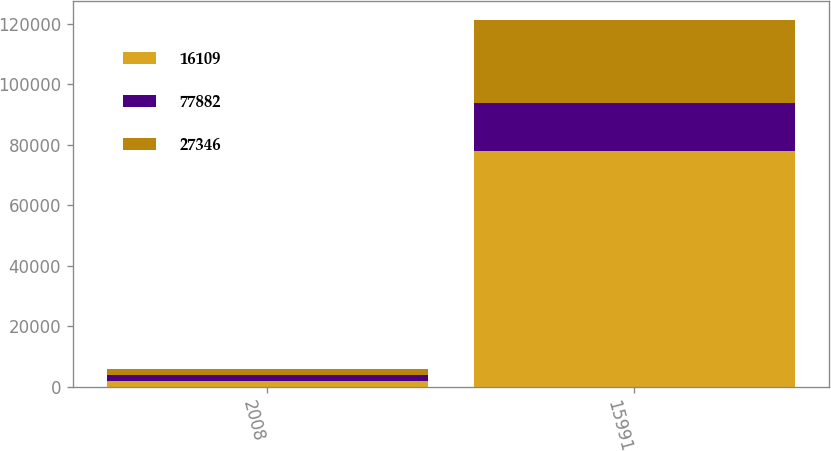<chart> <loc_0><loc_0><loc_500><loc_500><stacked_bar_chart><ecel><fcel>2008<fcel>15991<nl><fcel>16109<fcel>2007<fcel>77882<nl><fcel>77882<fcel>2006<fcel>16109<nl><fcel>27346<fcel>2005<fcel>27346<nl></chart> 